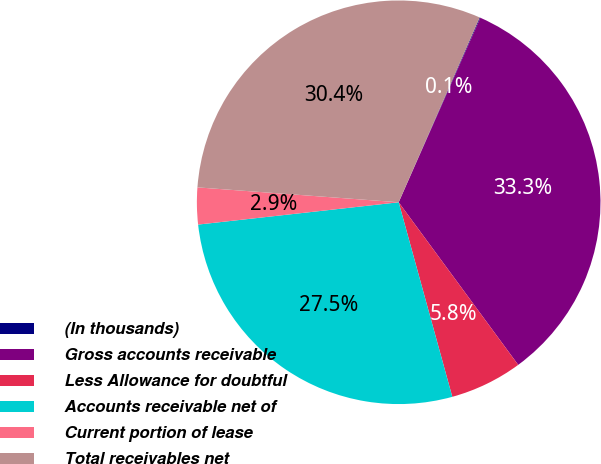<chart> <loc_0><loc_0><loc_500><loc_500><pie_chart><fcel>(In thousands)<fcel>Gross accounts receivable<fcel>Less Allowance for doubtful<fcel>Accounts receivable net of<fcel>Current portion of lease<fcel>Total receivables net<nl><fcel>0.06%<fcel>33.28%<fcel>5.81%<fcel>27.52%<fcel>2.94%<fcel>30.4%<nl></chart> 